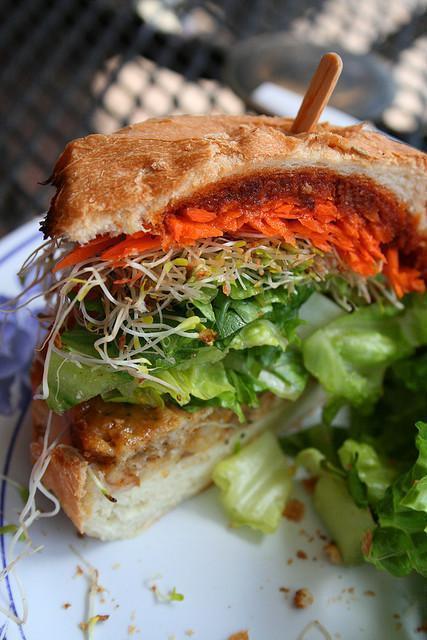This sandwich is probably being eaten in what kind of setting?
Select the accurate answer and provide justification: `Answer: choice
Rationale: srationale.`
Options: Outdoor, office, cafeteria, kitchen. Answer: outdoor.
Rationale: The table is the kind seen on patios and sunlight is visible through it. 